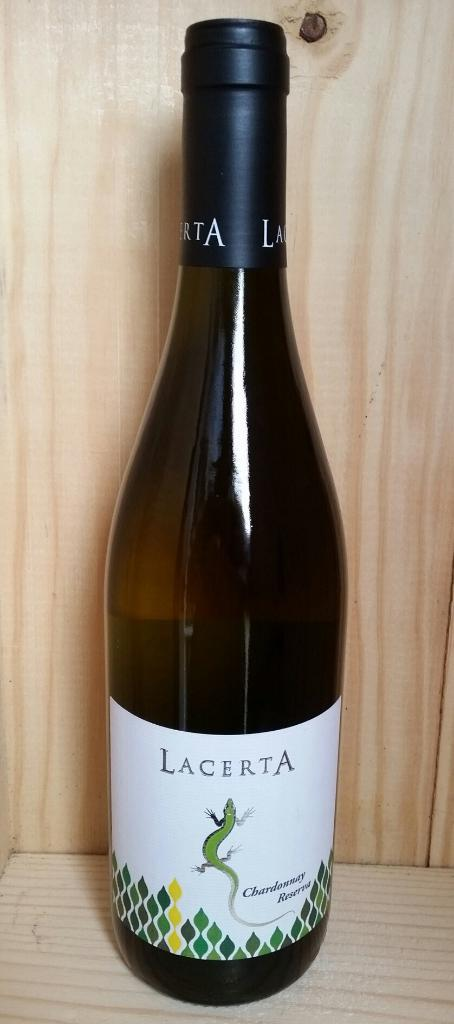<image>
Write a terse but informative summary of the picture. a bottle of wine with Lacerta and a lizard on it 